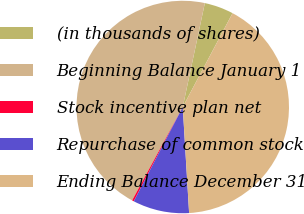<chart> <loc_0><loc_0><loc_500><loc_500><pie_chart><fcel>(in thousands of shares)<fcel>Beginning Balance January 1<fcel>Stock incentive plan net<fcel>Repurchase of common stock<fcel>Ending Balance December 31<nl><fcel>4.43%<fcel>45.43%<fcel>0.28%<fcel>8.58%<fcel>41.28%<nl></chart> 